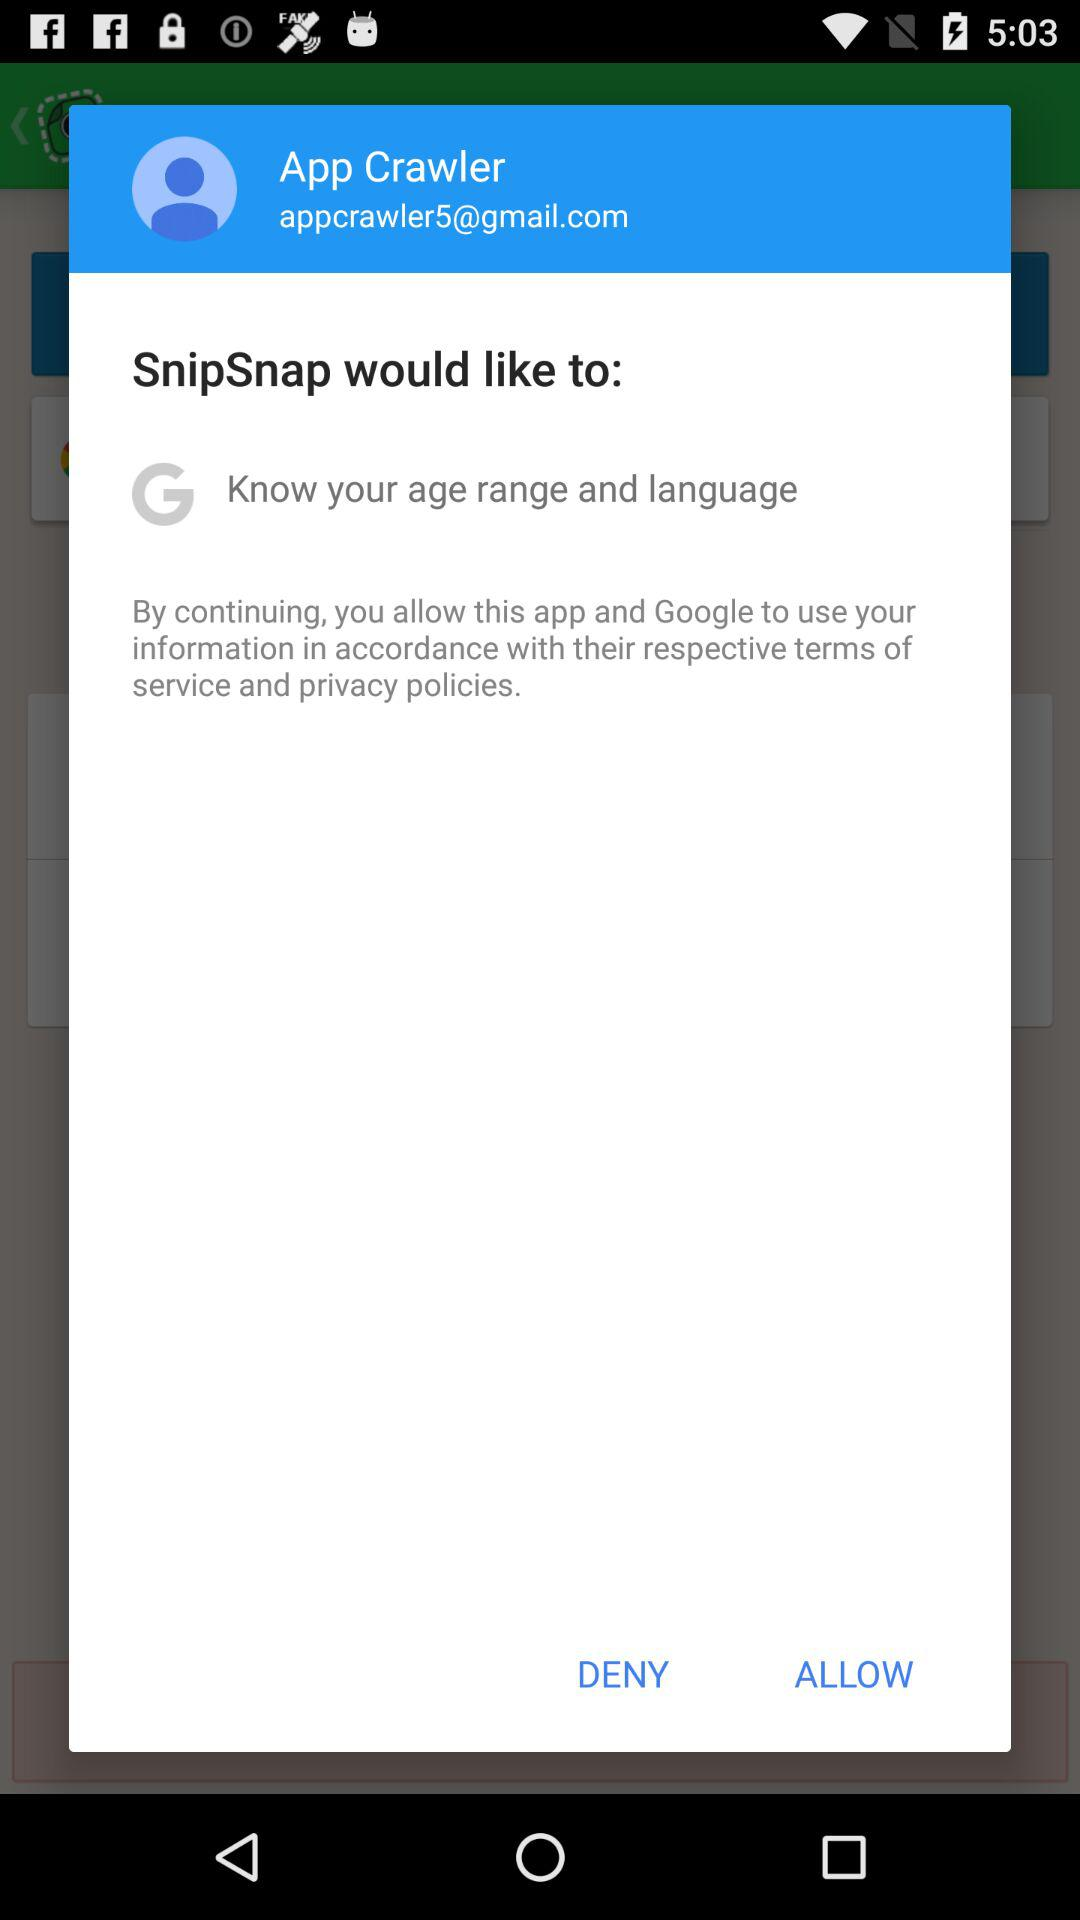What is the email address? The email address is appcrawler5@gmail.com. 